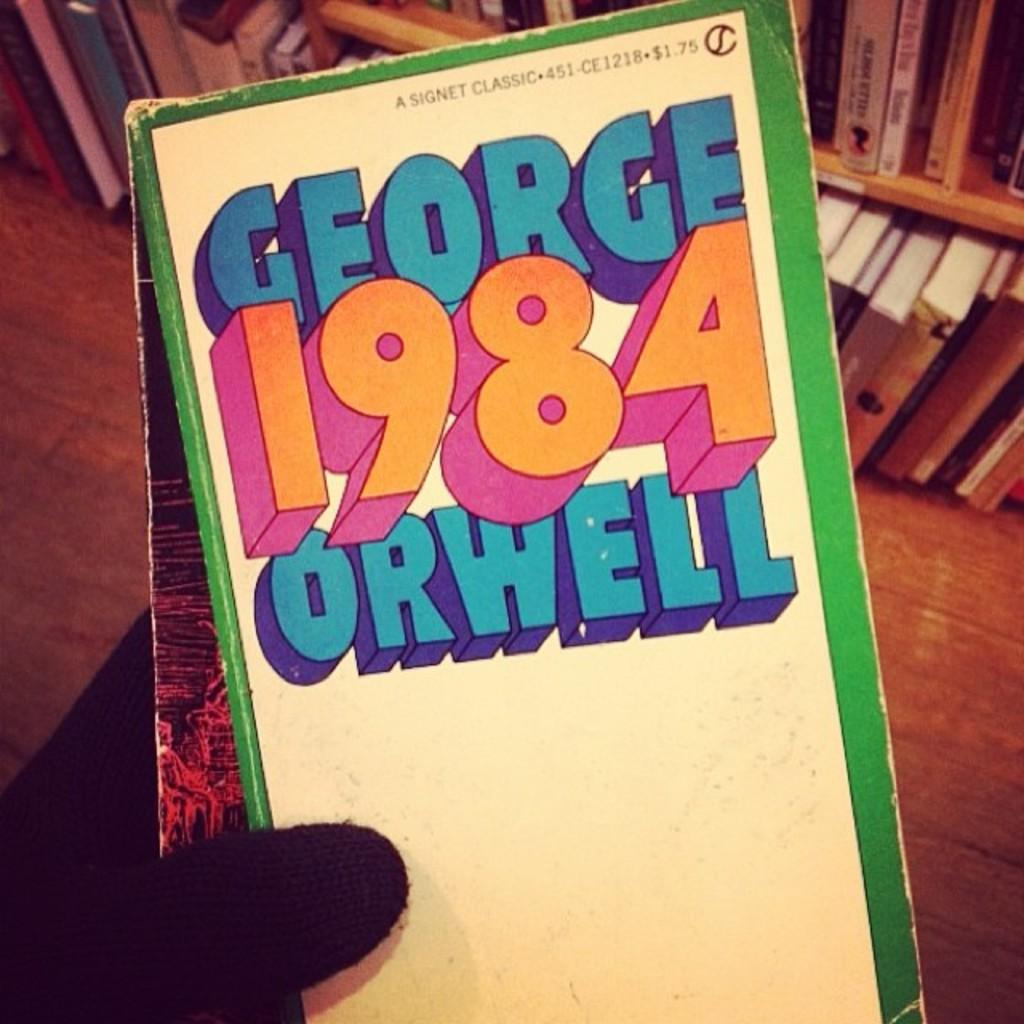<image>
Offer a succinct explanation of the picture presented. the book 1984 has the name George Orwell on it 